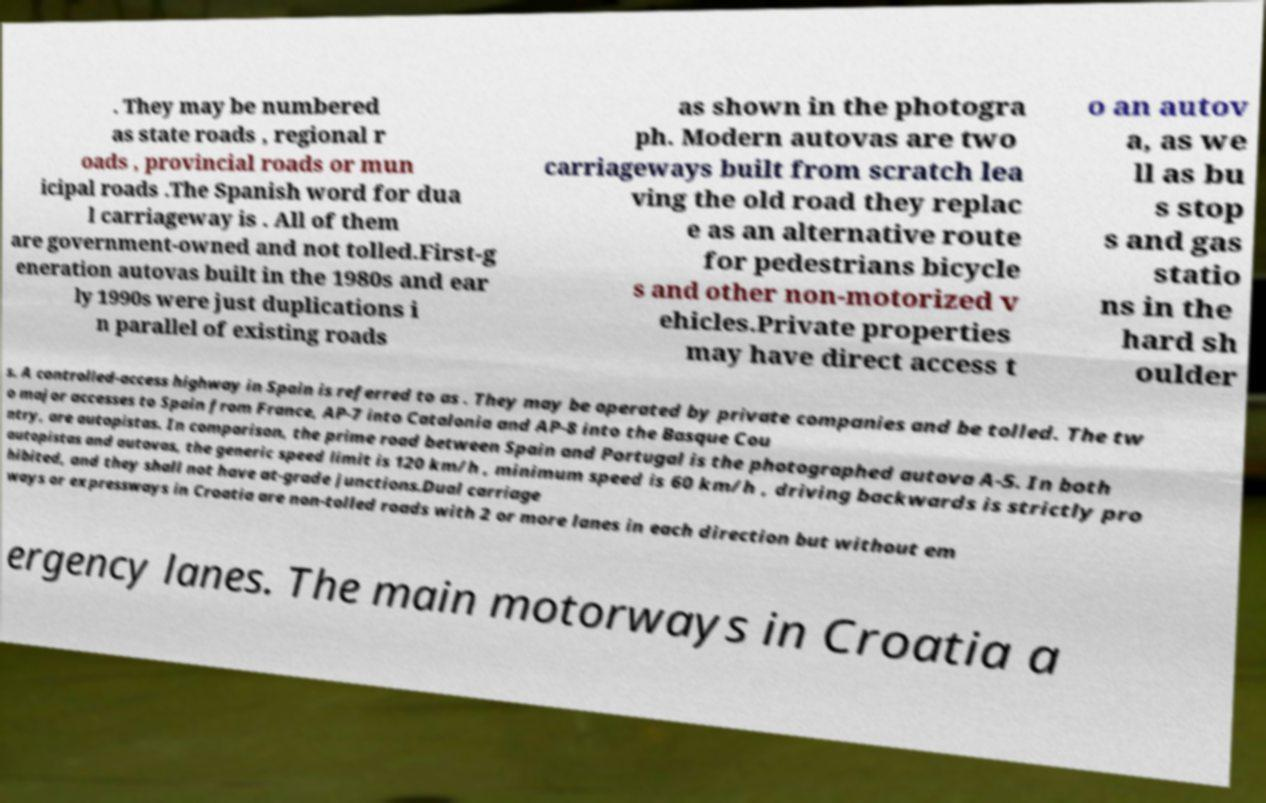For documentation purposes, I need the text within this image transcribed. Could you provide that? . They may be numbered as state roads , regional r oads , provincial roads or mun icipal roads .The Spanish word for dua l carriageway is . All of them are government-owned and not tolled.First-g eneration autovas built in the 1980s and ear ly 1990s were just duplications i n parallel of existing roads as shown in the photogra ph. Modern autovas are two carriageways built from scratch lea ving the old road they replac e as an alternative route for pedestrians bicycle s and other non-motorized v ehicles.Private properties may have direct access t o an autov a, as we ll as bu s stop s and gas statio ns in the hard sh oulder s. A controlled-access highway in Spain is referred to as . They may be operated by private companies and be tolled. The tw o major accesses to Spain from France, AP-7 into Catalonia and AP-8 into the Basque Cou ntry, are autopistas. In comparison, the prime road between Spain and Portugal is the photographed autova A-5. In both autopistas and autovas, the generic speed limit is 120 km/h , minimum speed is 60 km/h , driving backwards is strictly pro hibited, and they shall not have at-grade junctions.Dual carriage ways or expressways in Croatia are non-tolled roads with 2 or more lanes in each direction but without em ergency lanes. The main motorways in Croatia a 